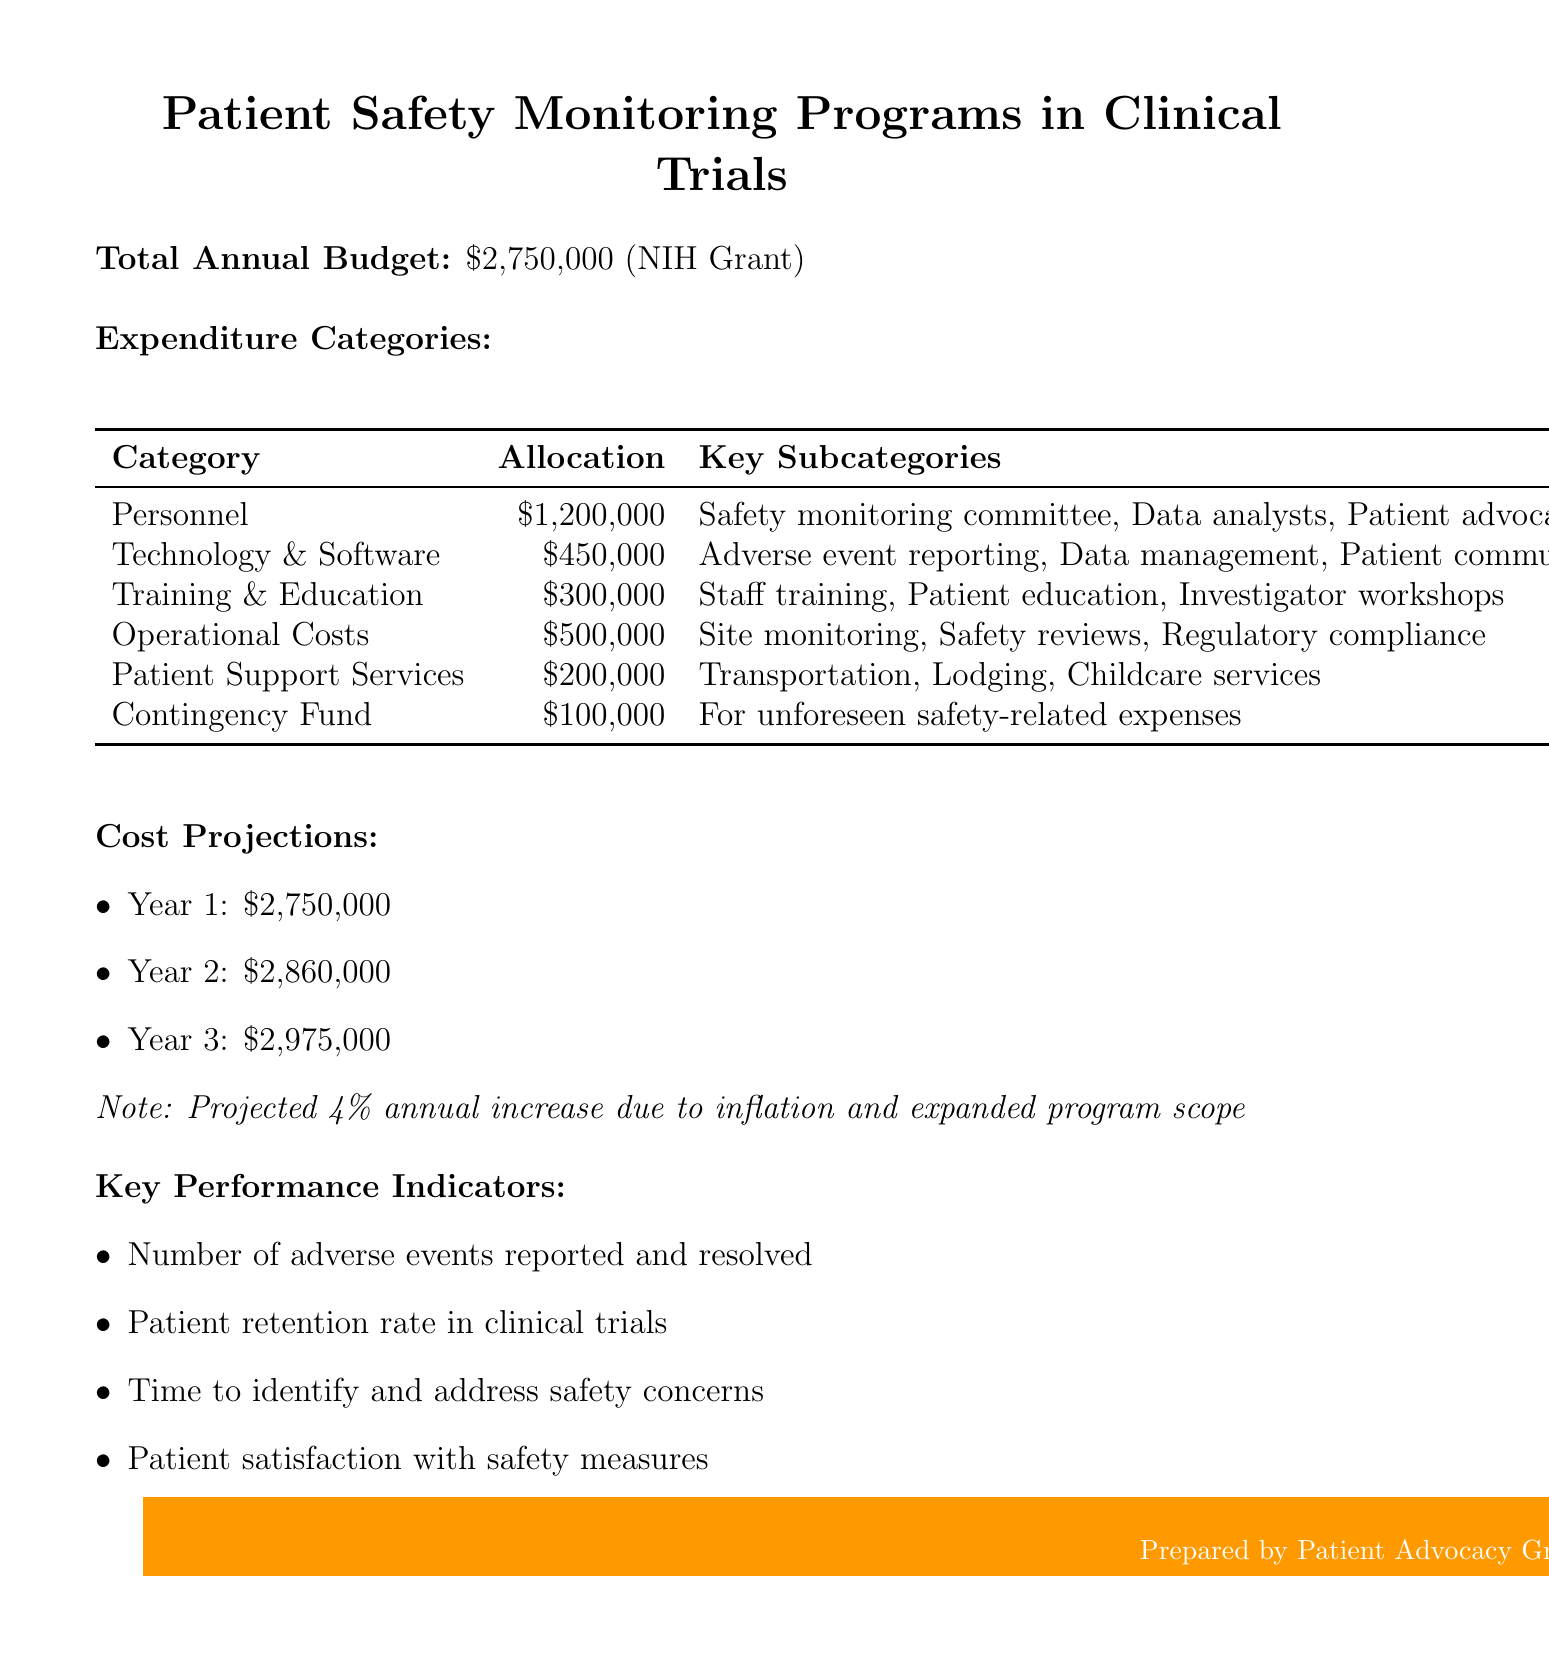what is the total annual budget? The total annual budget is specifically mentioned in the document as the overall amount allocated for patient safety monitoring programs.
Answer: $2,750,000 who is the funding source for the budget? The document states that the funding source for the annual budget allocation comes from a specific organization, which is responsible for the grant.
Answer: National Institutes of Health (NIH) grant how much is allocated for Personnel? The expenditure for the Personnel category is broken down in the document, detailing the specific allocation directed towards staff.
Answer: $1,200,000 what is the allocation for Technology and Software? This refers to the part of the budget designated for technological needs, as outlined in a specific expenditure category.
Answer: $450,000 what is the projected budget for Year 2? This figure shows the anticipated financial commitment in the second year, based on the growth expectations outlined in the document.
Answer: $2,860,000 how much is designated for Patient Support Services? This allocation is specifically mentioned within the expenditure categories, focusing on supporting patients during clinical trials.
Answer: $200,000 what is included in the Contingency Fund? The document specifies the purpose of the contingency fund, indicating its role in addressing unexpected costs.
Answer: For unforeseen safety-related expenses what is the annual increase rate projected for the budget? This percentage reflects the anticipated annual adjustment in the budget over the coming years.
Answer: 4% what is one of the key performance indicators? The document lists specific indicators to measure the effectiveness of patient safety monitoring programs, with multiple examples given.
Answer: Number of adverse events reported and resolved 